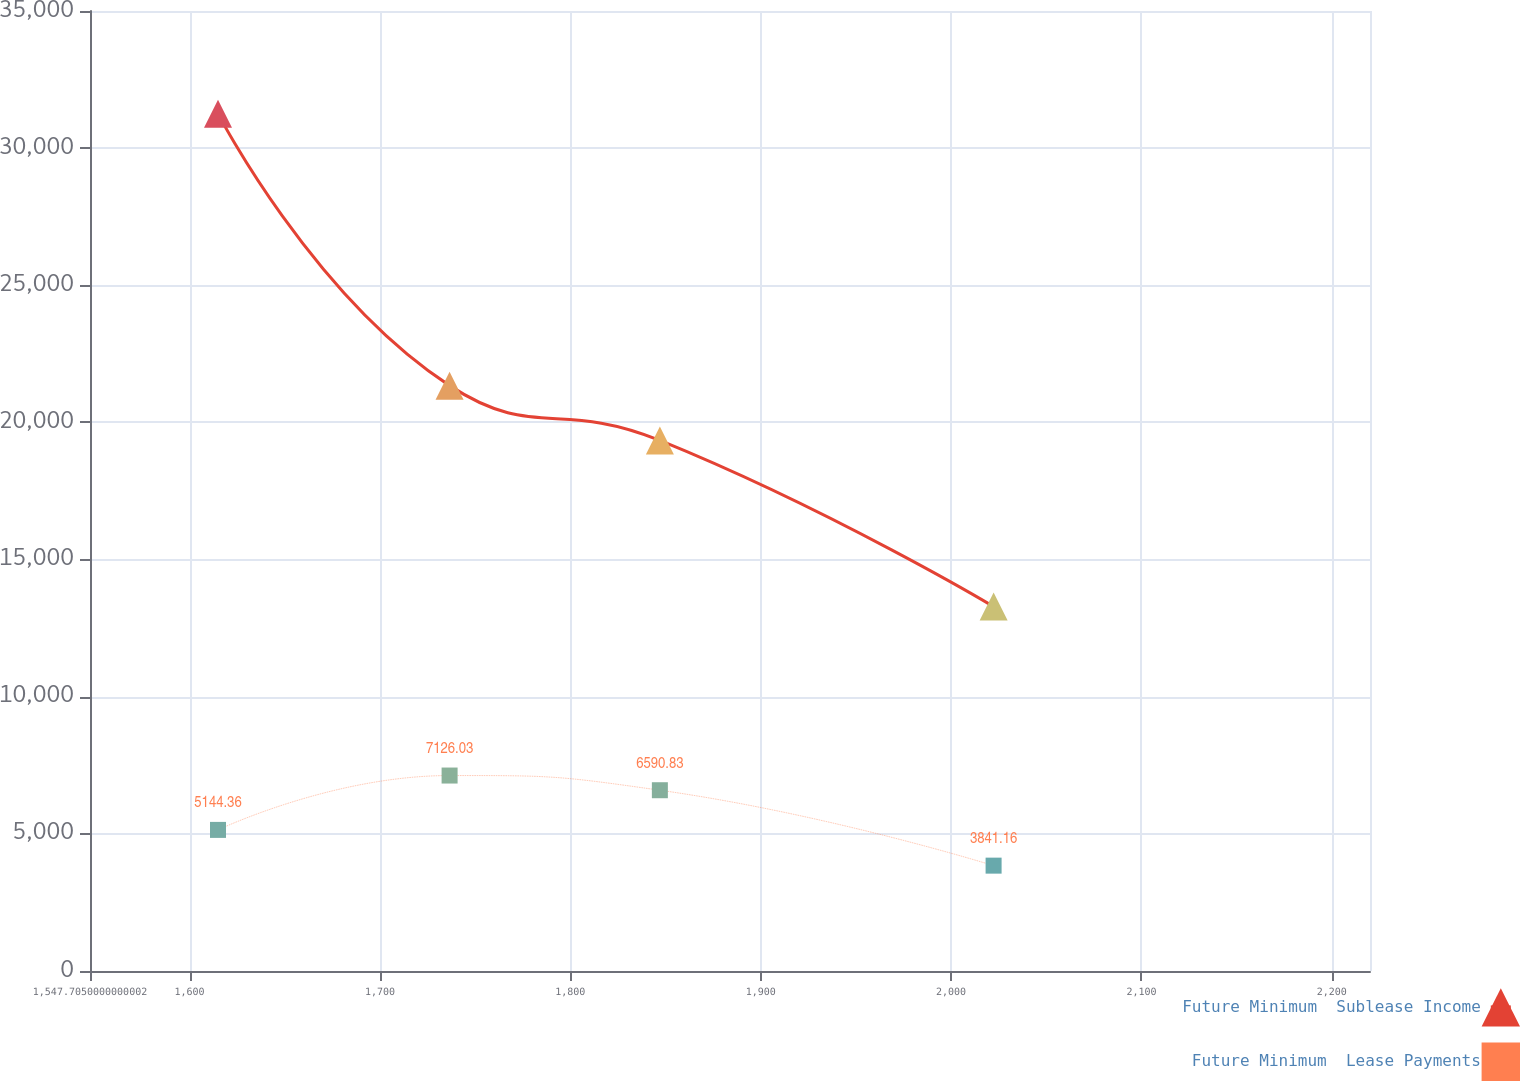Convert chart. <chart><loc_0><loc_0><loc_500><loc_500><line_chart><ecel><fcel>Future Minimum  Sublease Income<fcel>Future Minimum  Lease Payments<nl><fcel>1614.94<fcel>31258.2<fcel>5144.36<nl><fcel>1736.59<fcel>21341.7<fcel>7126.03<nl><fcel>1847.04<fcel>19344.6<fcel>6590.83<nl><fcel>2022.34<fcel>13284.7<fcel>3841.16<nl><fcel>2287.29<fcel>11287.7<fcel>1507.39<nl></chart> 